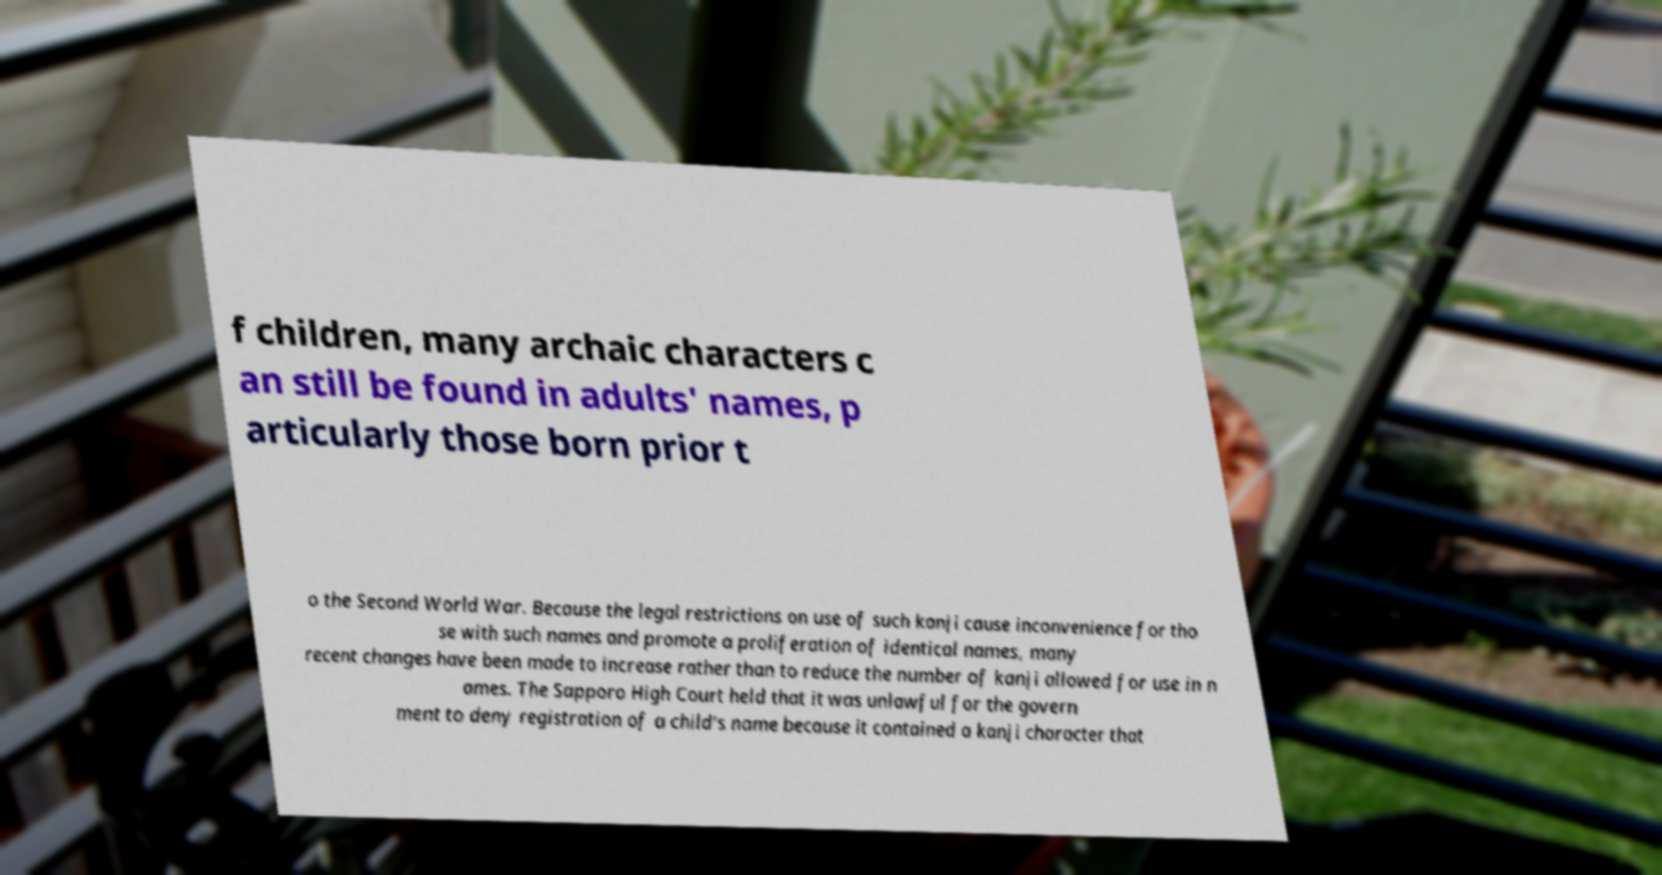Please identify and transcribe the text found in this image. f children, many archaic characters c an still be found in adults' names, p articularly those born prior t o the Second World War. Because the legal restrictions on use of such kanji cause inconvenience for tho se with such names and promote a proliferation of identical names, many recent changes have been made to increase rather than to reduce the number of kanji allowed for use in n ames. The Sapporo High Court held that it was unlawful for the govern ment to deny registration of a child's name because it contained a kanji character that 